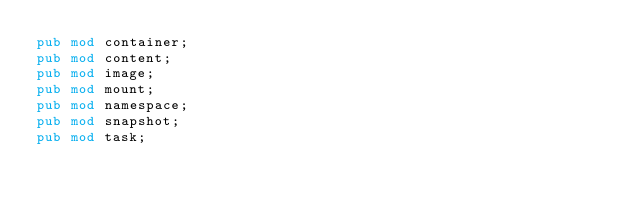<code> <loc_0><loc_0><loc_500><loc_500><_Rust_>pub mod container;
pub mod content;
pub mod image;
pub mod mount;
pub mod namespace;
pub mod snapshot;
pub mod task;
</code> 